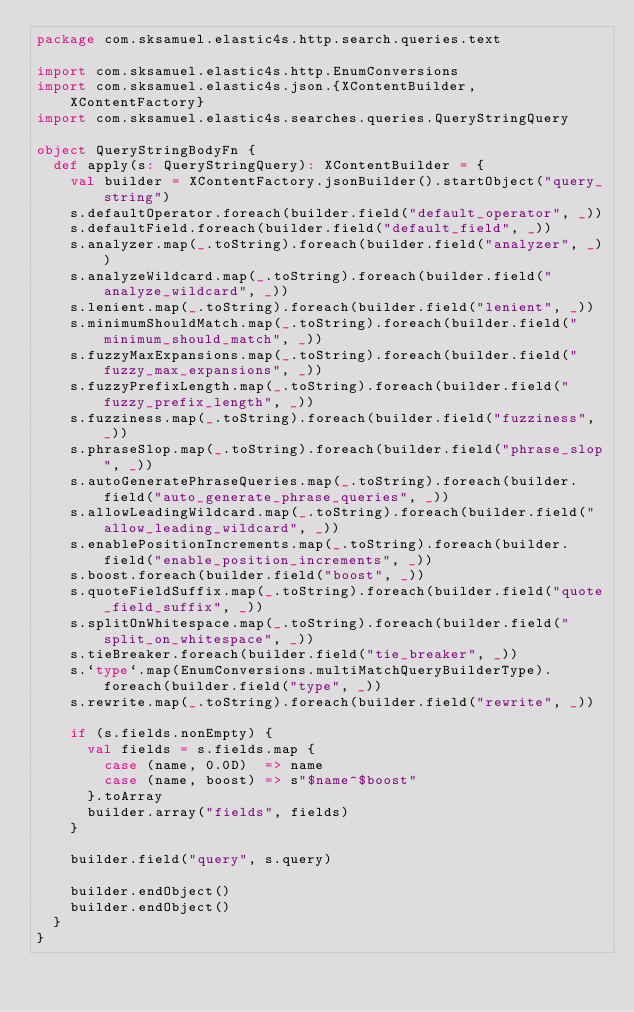<code> <loc_0><loc_0><loc_500><loc_500><_Scala_>package com.sksamuel.elastic4s.http.search.queries.text

import com.sksamuel.elastic4s.http.EnumConversions
import com.sksamuel.elastic4s.json.{XContentBuilder, XContentFactory}
import com.sksamuel.elastic4s.searches.queries.QueryStringQuery

object QueryStringBodyFn {
  def apply(s: QueryStringQuery): XContentBuilder = {
    val builder = XContentFactory.jsonBuilder().startObject("query_string")
    s.defaultOperator.foreach(builder.field("default_operator", _))
    s.defaultField.foreach(builder.field("default_field", _))
    s.analyzer.map(_.toString).foreach(builder.field("analyzer", _))
    s.analyzeWildcard.map(_.toString).foreach(builder.field("analyze_wildcard", _))
    s.lenient.map(_.toString).foreach(builder.field("lenient", _))
    s.minimumShouldMatch.map(_.toString).foreach(builder.field("minimum_should_match", _))
    s.fuzzyMaxExpansions.map(_.toString).foreach(builder.field("fuzzy_max_expansions", _))
    s.fuzzyPrefixLength.map(_.toString).foreach(builder.field("fuzzy_prefix_length", _))
    s.fuzziness.map(_.toString).foreach(builder.field("fuzziness", _))
    s.phraseSlop.map(_.toString).foreach(builder.field("phrase_slop", _))
    s.autoGeneratePhraseQueries.map(_.toString).foreach(builder.field("auto_generate_phrase_queries", _))
    s.allowLeadingWildcard.map(_.toString).foreach(builder.field("allow_leading_wildcard", _))
    s.enablePositionIncrements.map(_.toString).foreach(builder.field("enable_position_increments", _))
    s.boost.foreach(builder.field("boost", _))
    s.quoteFieldSuffix.map(_.toString).foreach(builder.field("quote_field_suffix", _))
    s.splitOnWhitespace.map(_.toString).foreach(builder.field("split_on_whitespace", _))
    s.tieBreaker.foreach(builder.field("tie_breaker", _))
    s.`type`.map(EnumConversions.multiMatchQueryBuilderType).foreach(builder.field("type", _))
    s.rewrite.map(_.toString).foreach(builder.field("rewrite", _))

    if (s.fields.nonEmpty) {
      val fields = s.fields.map {
        case (name, 0.0D)  => name
        case (name, boost) => s"$name^$boost"
      }.toArray
      builder.array("fields", fields)
    }

    builder.field("query", s.query)

    builder.endObject()
    builder.endObject()
  }
}
</code> 